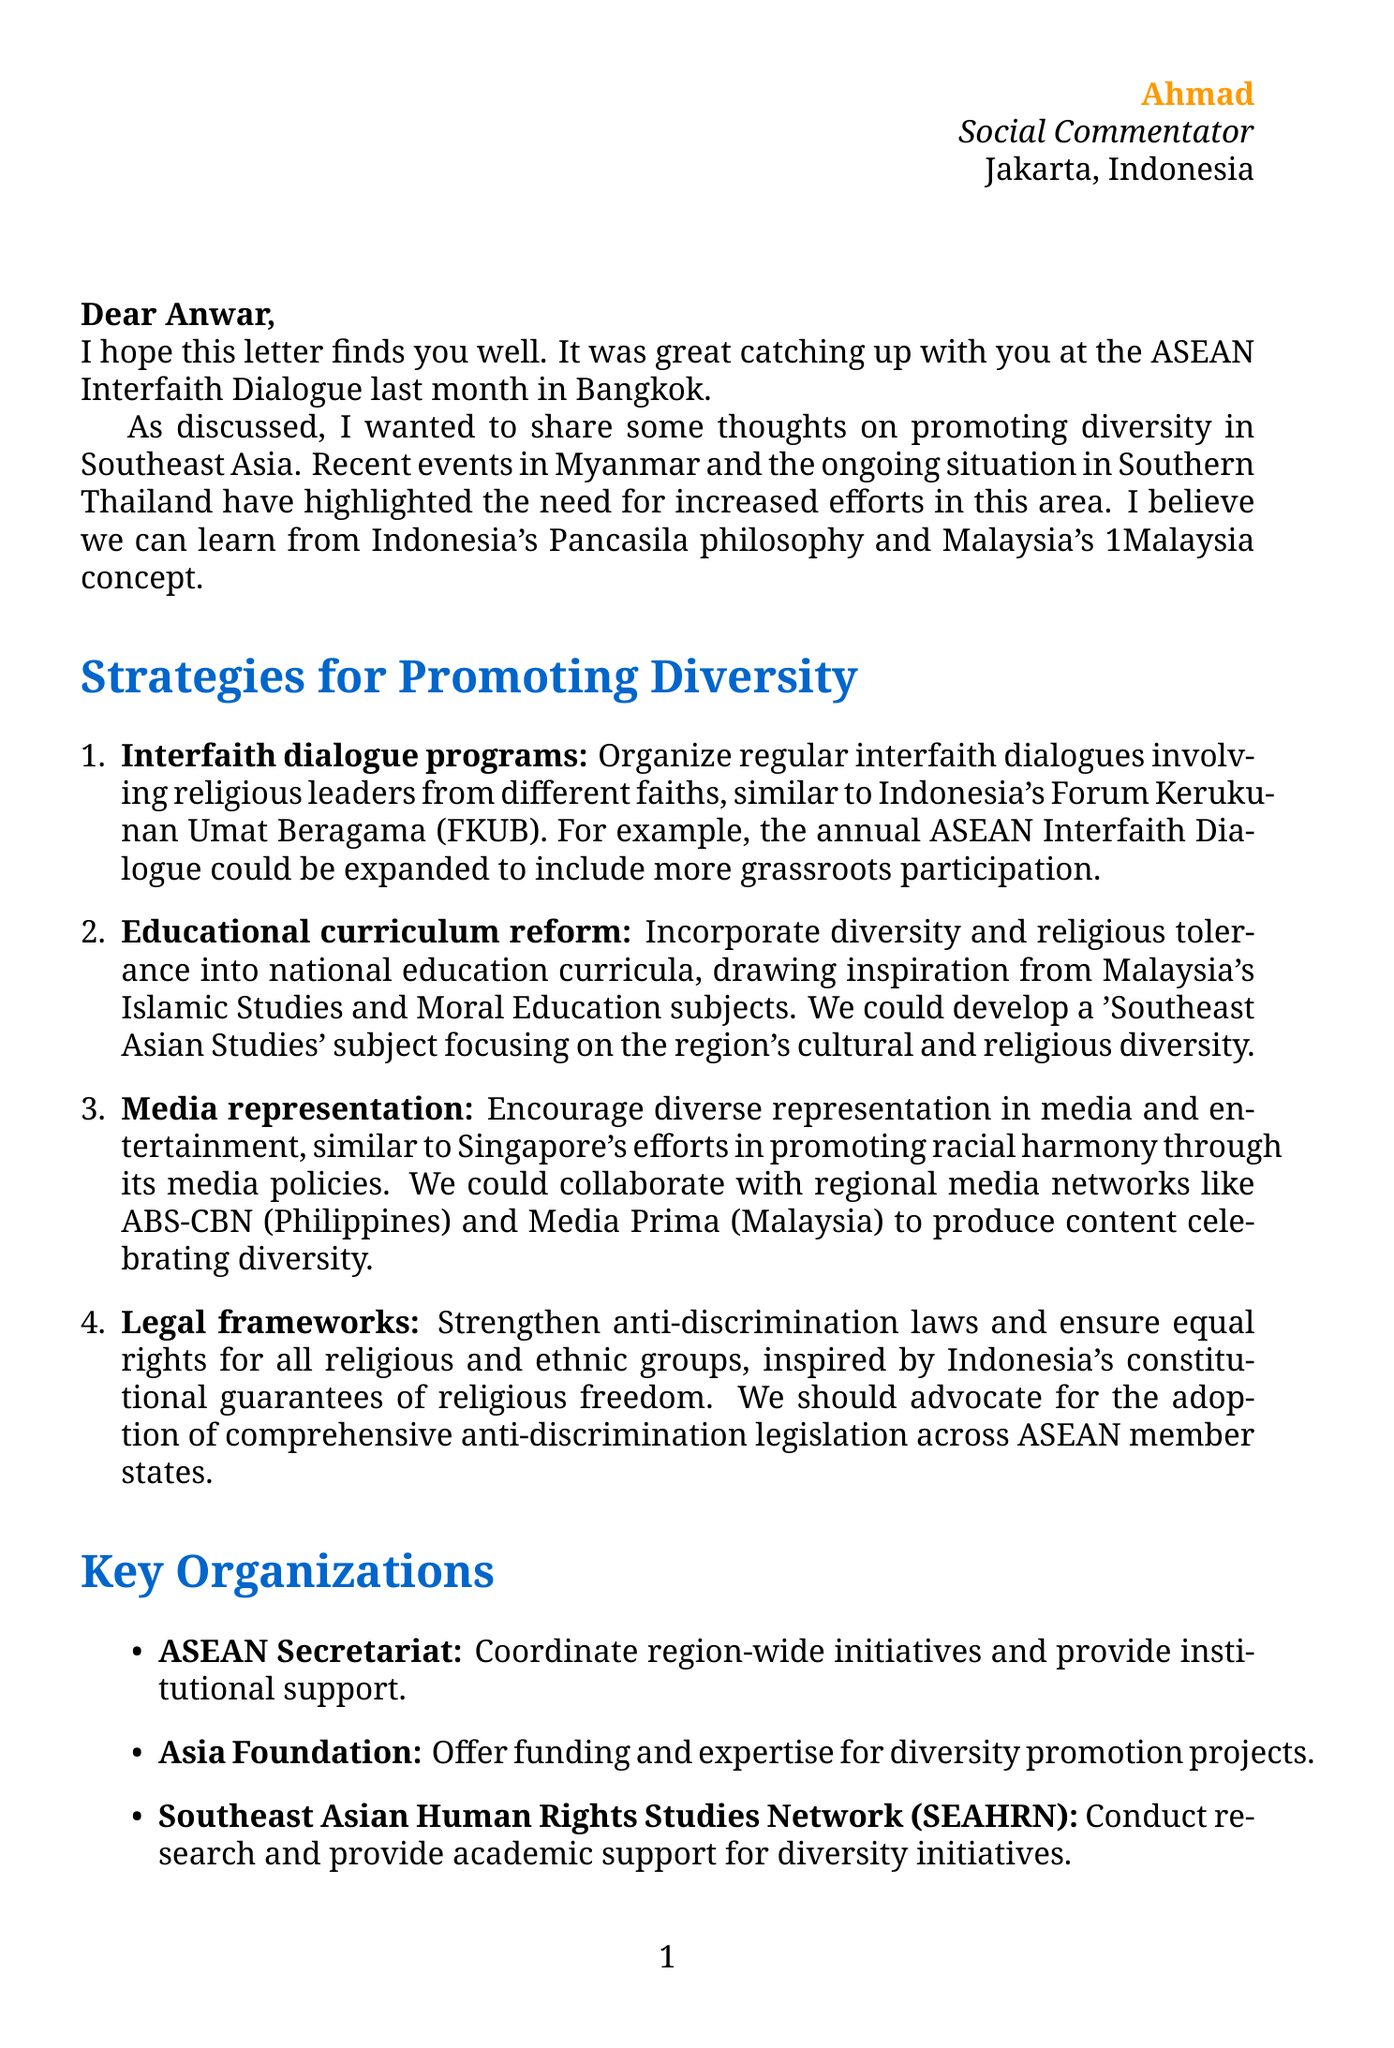What is the name of the sender? The sender is Ahmad, as indicated in the closing of the letter.
Answer: Ahmad What is the main event mentioned in the introduction? The introduction references the ASEAN Interfaith Dialogue that took place last month in Bangkok.
Answer: ASEAN Interfaith Dialogue Which country’s concept is referenced alongside Indonesia's Pancasila? The letter mentions Malaysia's 1Malaysia concept in relation to promoting diversity.
Answer: Malaysia's 1Malaysia What is one proposed strategy for promoting diversity? The letter lists several strategies, including interfaith dialogue programs as a key strategy.
Answer: Interfaith dialogue programs What organization is suggested to coordinate region-wide initiatives? The letter mentions ASEAN Secretariat as a key organization for coordination.
Answer: ASEAN Secretariat What challenge is noted regarding political dynamics in ASEAN member states? The document states there are varying levels of political will among ASEAN member states.
Answer: Varying levels of political will What personal reflection does the sender share regarding diversity? Ahmad reflects that Indonesia's experience with Bhinneka Tunggal Ika can serve as a valuable model for the region.
Answer: Bhinneka Tunggal Ika Which media networks are highlighted for collaboration on diversity content? The letter cites ABS-CBN from the Philippines and Media Prima from Malaysia as networks for collaboration.
Answer: ABS-CBN and Media Prima What does the sender look forward to? The sender expresses eagerness to collaborate on diversity initiatives and hopes to meet again.
Answer: Collaborating on these initiatives 